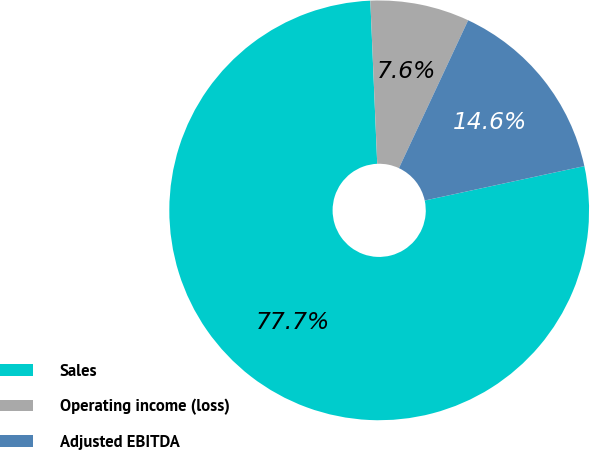Convert chart. <chart><loc_0><loc_0><loc_500><loc_500><pie_chart><fcel>Sales<fcel>Operating income (loss)<fcel>Adjusted EBITDA<nl><fcel>77.71%<fcel>7.64%<fcel>14.65%<nl></chart> 